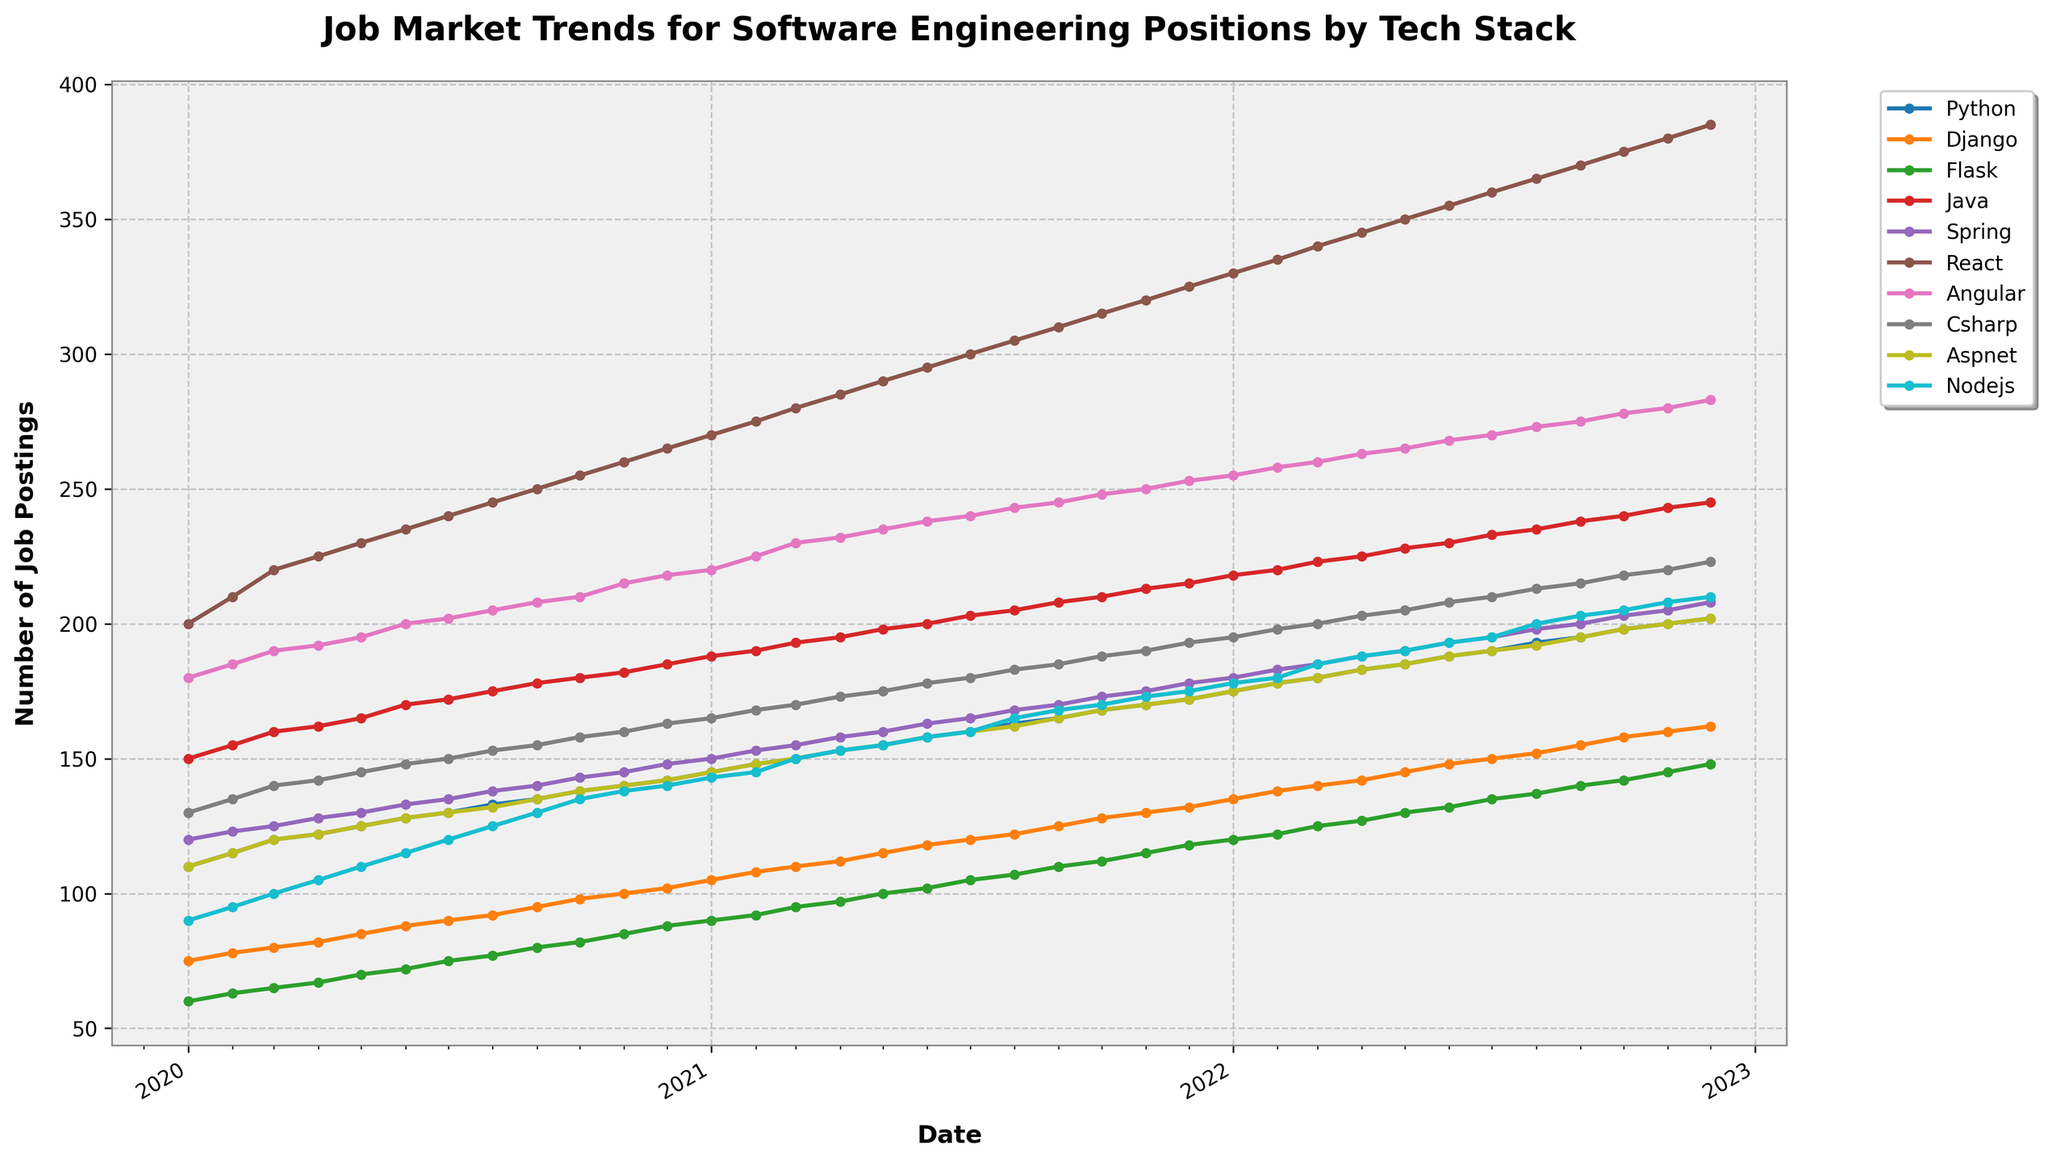What is the title of the plot? The title is found at the top of the plot and usually summarizes the main idea or subject of the chart. In this case, it reads "Job Market Trends for Software Engineering Positions by Tech Stack".
Answer: Job Market Trends for Software Engineering Positions by Tech Stack How many tech stacks are represented in the plot? The plot includes a legend that lists all tech stacks represented. Counting each unique entry in the legend gives the number. In this plot, the tech stacks include Python, Django, Flask, Java, Spring, React, Angular, C#, ASP.NET, and NodeJS.
Answer: 10 Which tech stack had the highest number of job postings in January 2021? Locate January 2021 on the x-axis and observe the y-values for all tech stacks. The highest y-value corresponds to the tech stack with the most job postings. In January 2021, React had the highest value.
Answer: React Between which two months did Python see the greatest increase in job postings? To find the greatest increase, calculate the difference in job postings for Python between each pair of consecutive months and identify the pair with the largest increase. Python saw the greatest increase between August and September 2020 (133 to 135).
Answer: August 2020 to September 2020 Which tech stack showed the most consistent growth in job postings over the entire period? Observe the trend lines for each tech stack. The one with the most uniform upward trajectory indicates consistent growth. Python's trend line appears the most consistent and consistently increasing over time.
Answer: Python In December 2022, how many more job postings were there for React compared to Angular? Locate December 2022 on the x-axis, find the values for React and Angular, and subtract them. React had 385 job postings, and Angular had 283 job postings. The difference is 385 - 283 = 102.
Answer: 102 Which tech stack started with fewer than 100 job postings at the beginning of the period and ended with more than 200 job postings? Check the job postings for each tech stack in January 2020 and December 2022. Flask started with 60 and ended with 148 postings. NodeJS started with 90 and ended with 210 postings. Both meet the criteria.
Answer: Flask, NodeJS How did the number of job postings for C# in the first month compare to ASP.NET in the last month? Locate January 2020 for C# and December 2022 for ASP.NET on the plot. C# had 130 job postings in January 2020 and ASP.NET had 223 in December 2022. Compare the two values.
Answer: C# had fewer than ASP.NET Which tech stack surpasses Java in job postings first, and in which month? Track the trend lines of all tech stacks relative to Java. Identify the first instance where another tech stack’s line crosses and moves above Java’s line. React surpasses Java in job postings in February 2020.
Answer: React, February 2020 What is the total number of job postings across all tech stacks in May 2021? Sum the values for all tech stacks in May 2021. Python (155) + Django (115) + Flask (100) + Java (198) + Spring (160) + React (290) + Angular (235) + C# (175) + ASP.NET (155) + NodeJS (155) = 1738.
Answer: 1738 